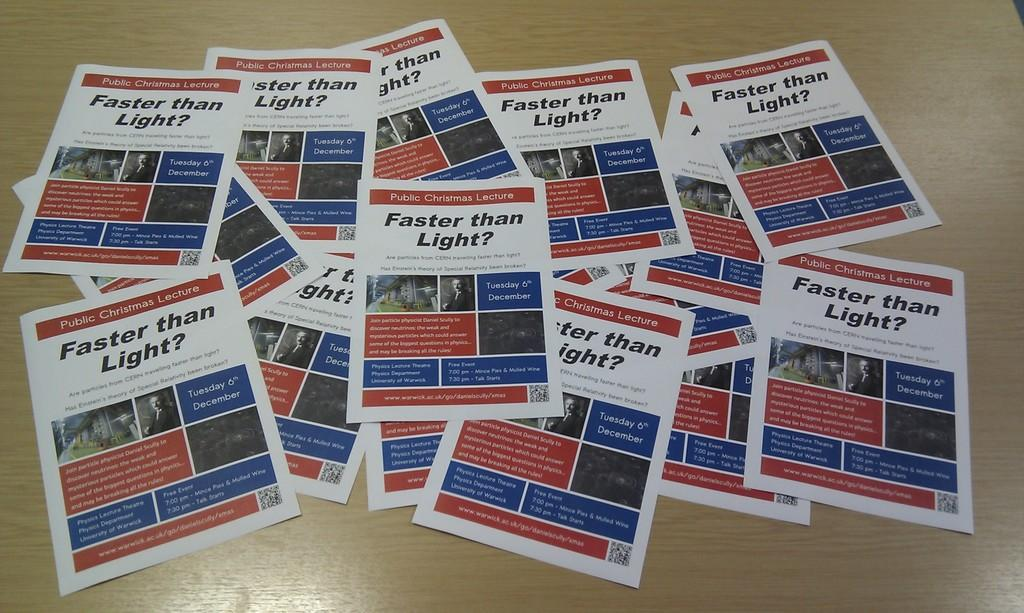What is on the table in the image? There are papers on a table in the image. What is the table made of? The table is made of wood. What can be found on the papers? The papers contain text and pictures. Where is the wren sitting on the table in the image? There is no wren present in the image. What type of river can be seen flowing through the image? There is no river present in the image. 